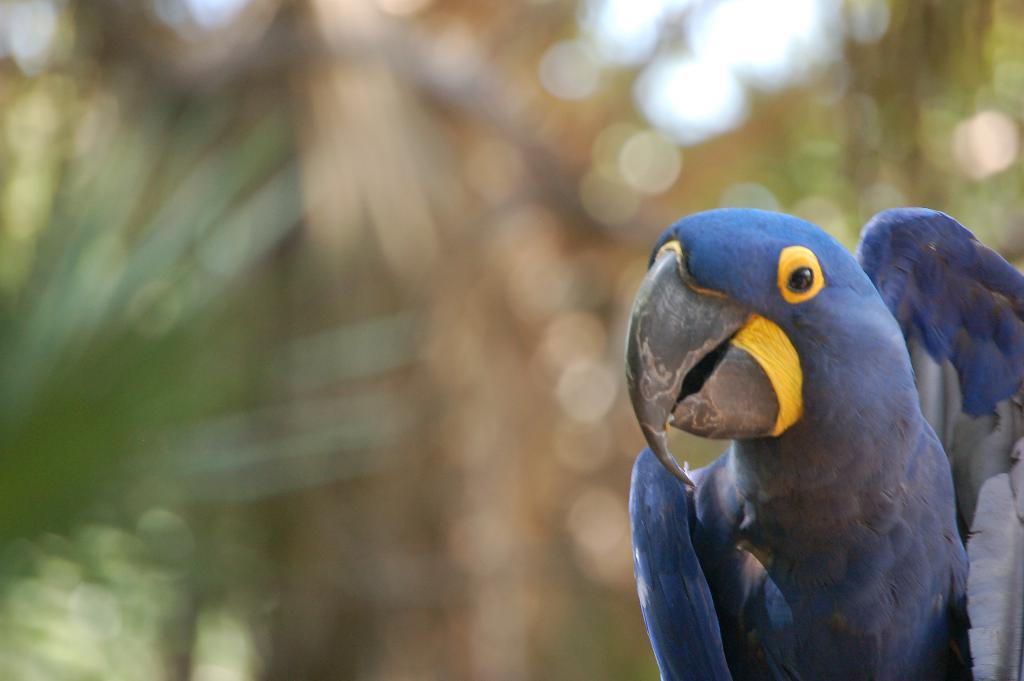What type of animal can be seen on the right side of the image? There is a bird on the right side of the image. How would you describe the background of the image? The background of the image is blurred. Can you identify any objects in the background of the image? Yes, there are objects visible in the background of the image. What type of notebook is being used by the bird in the image? There is no notebook present in the image, as it features a bird on the right side with a blurred background. 